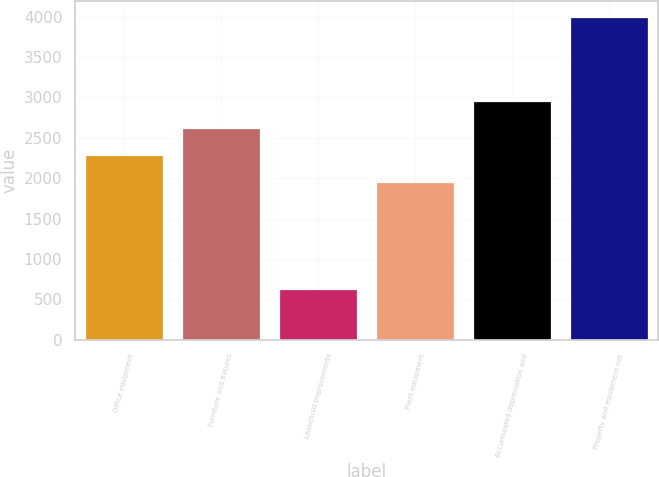Convert chart to OTSL. <chart><loc_0><loc_0><loc_500><loc_500><bar_chart><fcel>Office equipment<fcel>Furniture and fixtures<fcel>Leasehold improvements<fcel>Plant equipment<fcel>Accumulated depreciation and<fcel>Property and equipment net<nl><fcel>2286<fcel>2623<fcel>629<fcel>1949<fcel>2960<fcel>3999<nl></chart> 